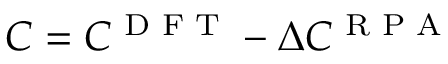Convert formula to latex. <formula><loc_0><loc_0><loc_500><loc_500>C = C ^ { D F T } - \Delta C ^ { R P A }</formula> 